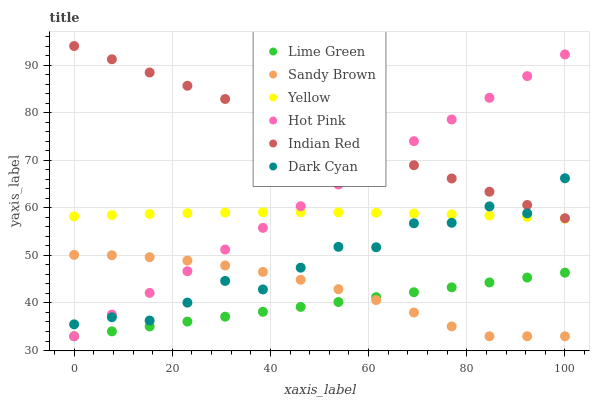Does Lime Green have the minimum area under the curve?
Answer yes or no. Yes. Does Indian Red have the maximum area under the curve?
Answer yes or no. Yes. Does Hot Pink have the minimum area under the curve?
Answer yes or no. No. Does Hot Pink have the maximum area under the curve?
Answer yes or no. No. Is Lime Green the smoothest?
Answer yes or no. Yes. Is Dark Cyan the roughest?
Answer yes or no. Yes. Is Hot Pink the smoothest?
Answer yes or no. No. Is Hot Pink the roughest?
Answer yes or no. No. Does Lime Green have the lowest value?
Answer yes or no. Yes. Does Yellow have the lowest value?
Answer yes or no. No. Does Indian Red have the highest value?
Answer yes or no. Yes. Does Hot Pink have the highest value?
Answer yes or no. No. Is Lime Green less than Dark Cyan?
Answer yes or no. Yes. Is Yellow greater than Sandy Brown?
Answer yes or no. Yes. Does Hot Pink intersect Dark Cyan?
Answer yes or no. Yes. Is Hot Pink less than Dark Cyan?
Answer yes or no. No. Is Hot Pink greater than Dark Cyan?
Answer yes or no. No. Does Lime Green intersect Dark Cyan?
Answer yes or no. No. 